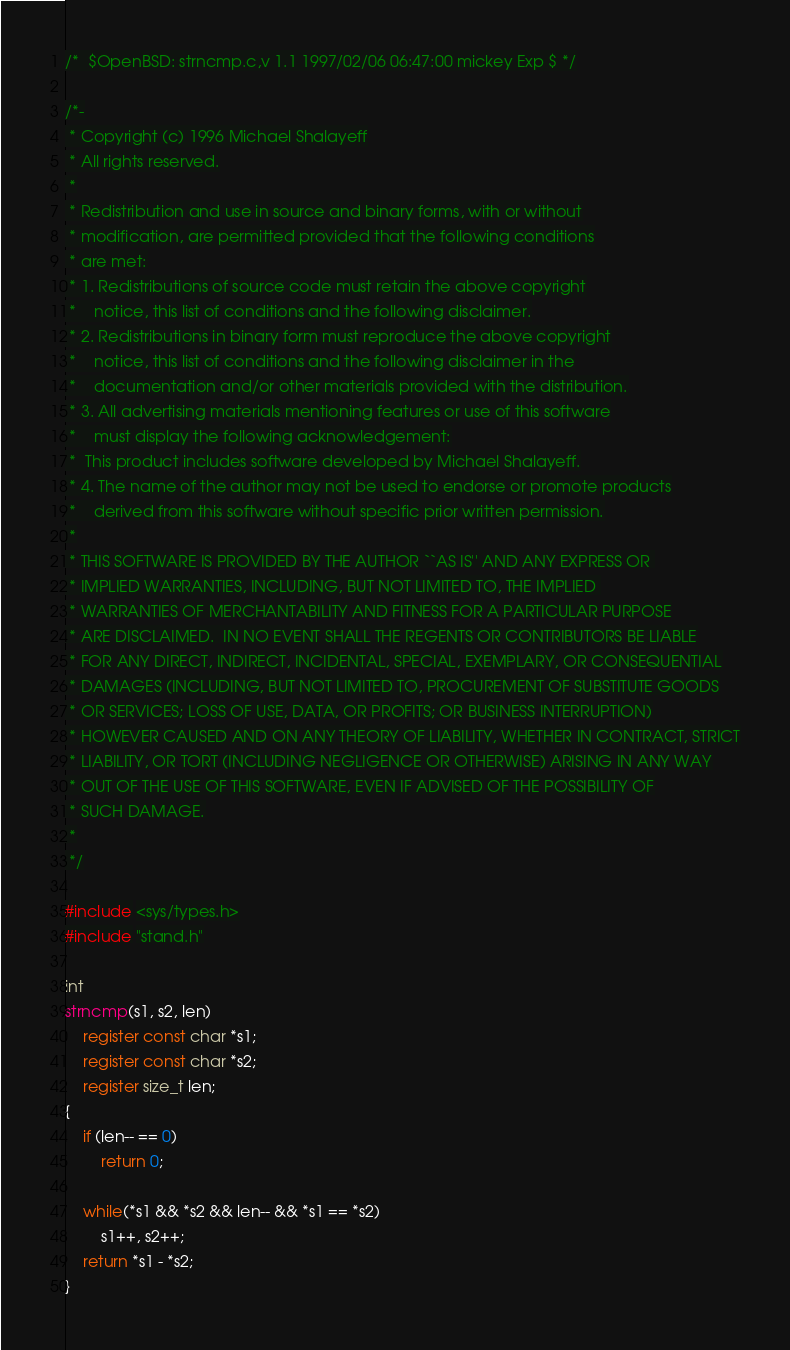<code> <loc_0><loc_0><loc_500><loc_500><_C_>/*	$OpenBSD: strncmp.c,v 1.1 1997/02/06 06:47:00 mickey Exp $ */

/*-
 * Copyright (c) 1996 Michael Shalayeff
 * All rights reserved.
 *
 * Redistribution and use in source and binary forms, with or without
 * modification, are permitted provided that the following conditions
 * are met:
 * 1. Redistributions of source code must retain the above copyright
 *    notice, this list of conditions and the following disclaimer.
 * 2. Redistributions in binary form must reproduce the above copyright
 *    notice, this list of conditions and the following disclaimer in the
 *    documentation and/or other materials provided with the distribution.
 * 3. All advertising materials mentioning features or use of this software
 *    must display the following acknowledgement:
 *	This product includes software developed by Michael Shalayeff.
 * 4. The name of the author may not be used to endorse or promote products
 *    derived from this software without specific prior written permission.
 *
 * THIS SOFTWARE IS PROVIDED BY THE AUTHOR ``AS IS'' AND ANY EXPRESS OR 
 * IMPLIED WARRANTIES, INCLUDING, BUT NOT LIMITED TO, THE IMPLIED 
 * WARRANTIES OF MERCHANTABILITY AND FITNESS FOR A PARTICULAR PURPOSE
 * ARE DISCLAIMED.  IN NO EVENT SHALL THE REGENTS OR CONTRIBUTORS BE LIABLE
 * FOR ANY DIRECT, INDIRECT, INCIDENTAL, SPECIAL, EXEMPLARY, OR CONSEQUENTIAL
 * DAMAGES (INCLUDING, BUT NOT LIMITED TO, PROCUREMENT OF SUBSTITUTE GOODS
 * OR SERVICES; LOSS OF USE, DATA, OR PROFITS; OR BUSINESS INTERRUPTION)
 * HOWEVER CAUSED AND ON ANY THEORY OF LIABILITY, WHETHER IN CONTRACT, STRICT
 * LIABILITY, OR TORT (INCLUDING NEGLIGENCE OR OTHERWISE) ARISING IN ANY WAY
 * OUT OF THE USE OF THIS SOFTWARE, EVEN IF ADVISED OF THE POSSIBILITY OF
 * SUCH DAMAGE.
 *
 */

#include <sys/types.h>
#include "stand.h"

int
strncmp(s1, s2, len)
	register const char *s1;
	register const char *s2;
	register size_t len;
{
	if (len-- == 0)
		return 0;

	while(*s1 && *s2 && len-- && *s1 == *s2)
		s1++, s2++;
	return *s1 - *s2;
}
</code> 